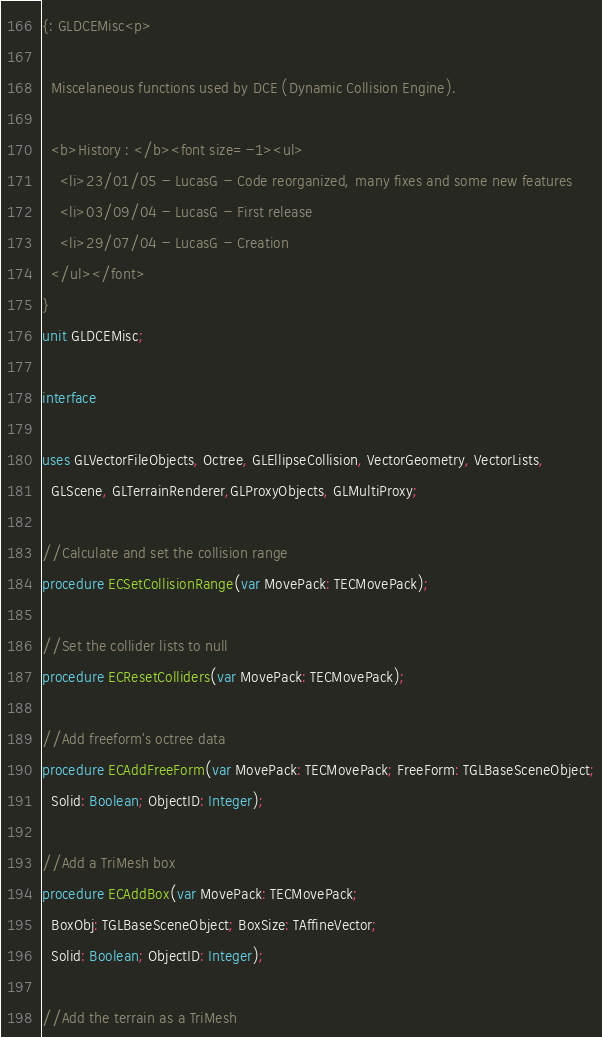Convert code to text. <code><loc_0><loc_0><loc_500><loc_500><_Pascal_>{: GLDCEMisc<p>

  Miscelaneous functions used by DCE (Dynamic Collision Engine).

  <b>History : </b><font size=-1><ul>
    <li>23/01/05 - LucasG - Code reorganized, many fixes and some new features 
    <li>03/09/04 - LucasG - First release
    <li>29/07/04 - LucasG - Creation
  </ul></font>
}
unit GLDCEMisc;

interface

uses GLVectorFileObjects, Octree, GLEllipseCollision, VectorGeometry, VectorLists,
  GLScene, GLTerrainRenderer,GLProxyObjects, GLMultiProxy;

//Calculate and set the collision range
procedure ECSetCollisionRange(var MovePack: TECMovePack);

//Set the collider lists to null
procedure ECResetColliders(var MovePack: TECMovePack);

//Add freeform's octree data
procedure ECAddFreeForm(var MovePack: TECMovePack; FreeForm: TGLBaseSceneObject;
  Solid: Boolean; ObjectID: Integer);

//Add a TriMesh box
procedure ECAddBox(var MovePack: TECMovePack;
  BoxObj: TGLBaseSceneObject; BoxSize: TAffineVector;
  Solid: Boolean; ObjectID: Integer);

//Add the terrain as a TriMesh</code> 